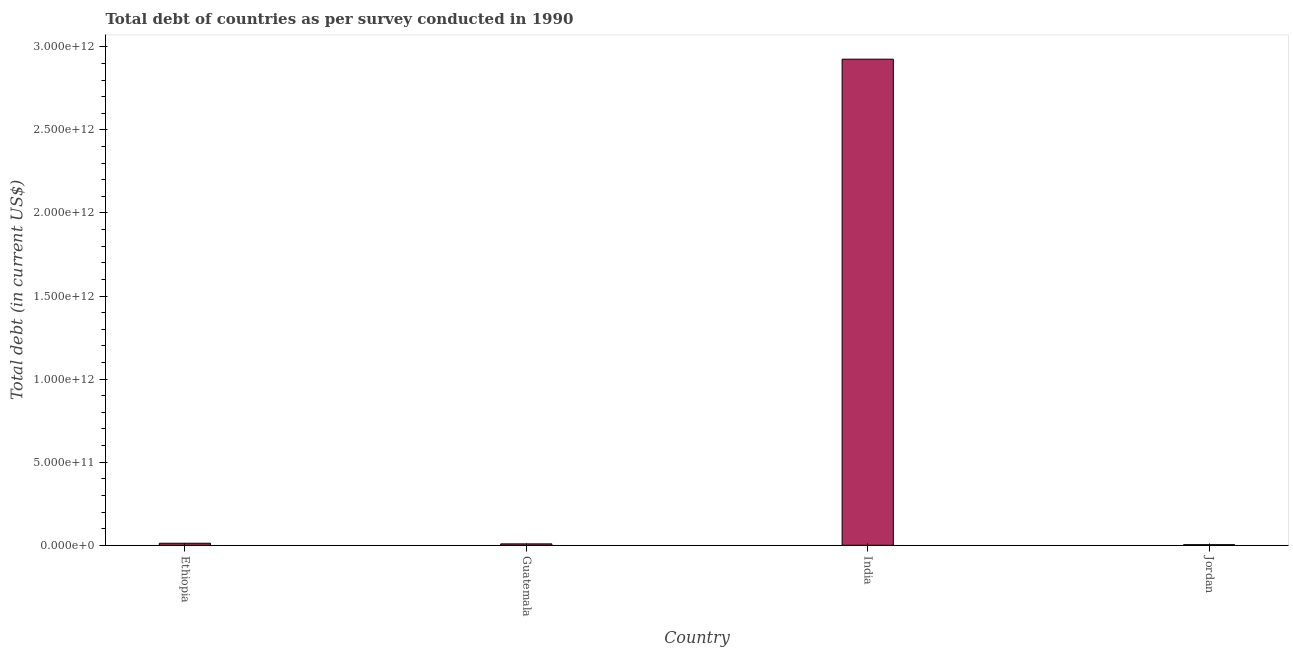Does the graph contain any zero values?
Offer a very short reply. No. Does the graph contain grids?
Your answer should be compact. No. What is the title of the graph?
Make the answer very short. Total debt of countries as per survey conducted in 1990. What is the label or title of the Y-axis?
Make the answer very short. Total debt (in current US$). What is the total debt in Ethiopia?
Give a very brief answer. 1.22e+1. Across all countries, what is the maximum total debt?
Provide a succinct answer. 2.93e+12. Across all countries, what is the minimum total debt?
Offer a terse response. 3.56e+09. In which country was the total debt maximum?
Give a very brief answer. India. In which country was the total debt minimum?
Provide a succinct answer. Jordan. What is the sum of the total debt?
Offer a very short reply. 2.95e+12. What is the difference between the total debt in Guatemala and India?
Keep it short and to the point. -2.92e+12. What is the average total debt per country?
Ensure brevity in your answer.  7.37e+11. What is the median total debt?
Keep it short and to the point. 1.03e+1. In how many countries, is the total debt greater than 200000000000 US$?
Provide a short and direct response. 1. What is the ratio of the total debt in Ethiopia to that in Guatemala?
Offer a very short reply. 1.45. Is the total debt in Ethiopia less than that in Guatemala?
Your response must be concise. No. Is the difference between the total debt in Guatemala and Jordan greater than the difference between any two countries?
Provide a succinct answer. No. What is the difference between the highest and the second highest total debt?
Your response must be concise. 2.91e+12. Is the sum of the total debt in Ethiopia and Guatemala greater than the maximum total debt across all countries?
Offer a terse response. No. What is the difference between the highest and the lowest total debt?
Ensure brevity in your answer.  2.92e+12. How many bars are there?
Your response must be concise. 4. Are all the bars in the graph horizontal?
Ensure brevity in your answer.  No. What is the difference between two consecutive major ticks on the Y-axis?
Provide a succinct answer. 5.00e+11. Are the values on the major ticks of Y-axis written in scientific E-notation?
Your response must be concise. Yes. What is the Total debt (in current US$) of Ethiopia?
Offer a very short reply. 1.22e+1. What is the Total debt (in current US$) in Guatemala?
Make the answer very short. 8.40e+09. What is the Total debt (in current US$) in India?
Offer a very short reply. 2.93e+12. What is the Total debt (in current US$) in Jordan?
Give a very brief answer. 3.56e+09. What is the difference between the Total debt (in current US$) in Ethiopia and Guatemala?
Ensure brevity in your answer.  3.79e+09. What is the difference between the Total debt (in current US$) in Ethiopia and India?
Give a very brief answer. -2.91e+12. What is the difference between the Total debt (in current US$) in Ethiopia and Jordan?
Offer a terse response. 8.63e+09. What is the difference between the Total debt (in current US$) in Guatemala and India?
Give a very brief answer. -2.92e+12. What is the difference between the Total debt (in current US$) in Guatemala and Jordan?
Your answer should be compact. 4.84e+09. What is the difference between the Total debt (in current US$) in India and Jordan?
Give a very brief answer. 2.92e+12. What is the ratio of the Total debt (in current US$) in Ethiopia to that in Guatemala?
Your answer should be compact. 1.45. What is the ratio of the Total debt (in current US$) in Ethiopia to that in India?
Ensure brevity in your answer.  0. What is the ratio of the Total debt (in current US$) in Ethiopia to that in Jordan?
Keep it short and to the point. 3.43. What is the ratio of the Total debt (in current US$) in Guatemala to that in India?
Provide a short and direct response. 0. What is the ratio of the Total debt (in current US$) in Guatemala to that in Jordan?
Give a very brief answer. 2.36. What is the ratio of the Total debt (in current US$) in India to that in Jordan?
Make the answer very short. 822.71. 